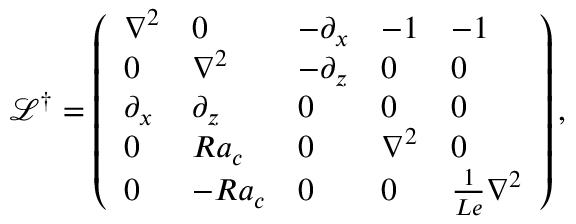Convert formula to latex. <formula><loc_0><loc_0><loc_500><loc_500>\mathcal { L } ^ { \dagger } = \left ( \begin{array} { l l l l l } { \nabla ^ { 2 } } & { 0 } & { - \partial _ { x } } & { - 1 } & { - 1 } \\ { 0 } & { \nabla ^ { 2 } } & { - \partial _ { z } } & { 0 } & { 0 } \\ { \partial _ { x } } & { \partial _ { z } } & { 0 } & { 0 } & { 0 } \\ { 0 } & { R a _ { c } } & { 0 } & { \nabla ^ { 2 } } & { 0 } \\ { 0 } & { - R a _ { c } } & { 0 } & { 0 } & { \frac { 1 } { L e } \nabla ^ { 2 } } \end{array} \right ) ,</formula> 